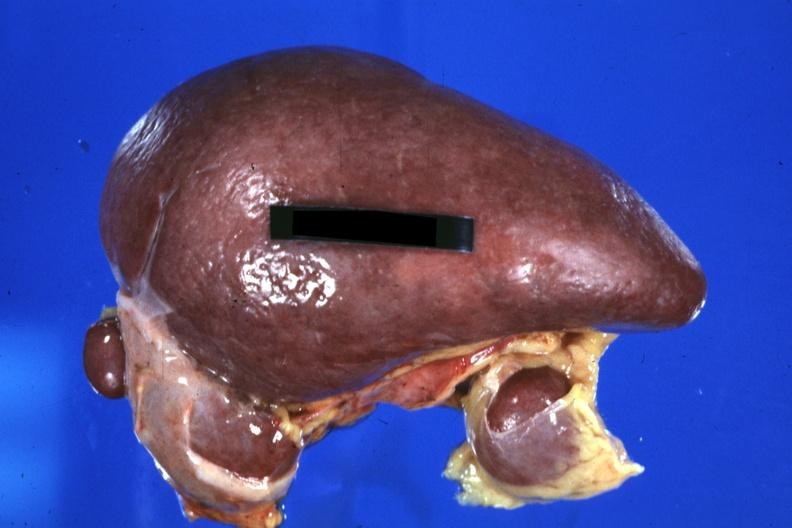what does this image show?
Answer the question using a single word or phrase. Spleen with three accessories 32yobf left isomerism and complex congenital heart disease 